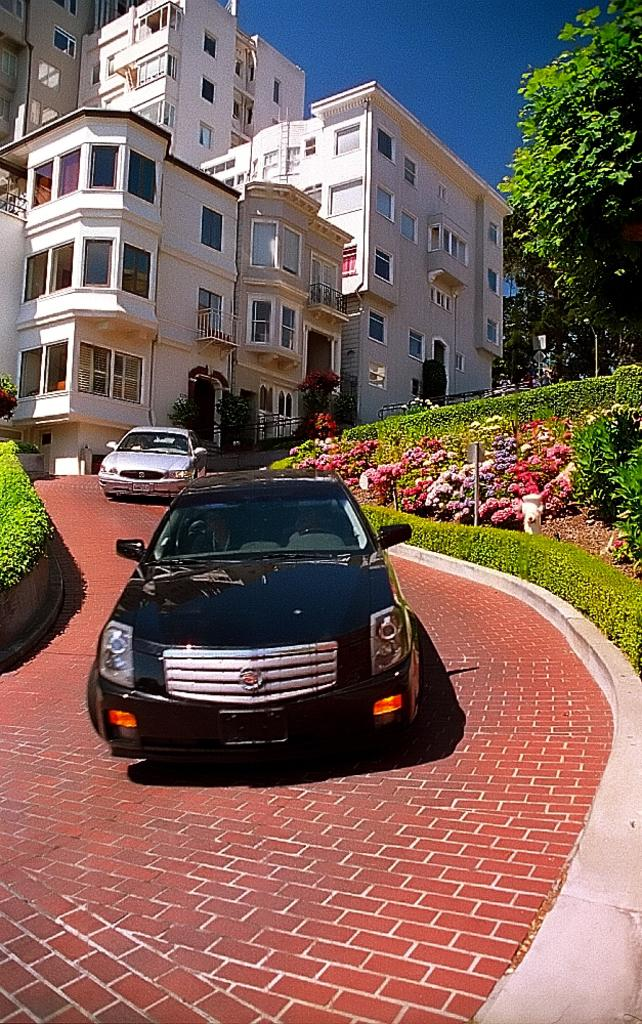What can be seen on the road in the image? There are cars parked on the road in the image. What is present on the plants in the image? There are flowers on the plants in the image. How many trees are visible in the image? There are many trees in the image. What type of structures can be seen in the image? There are buildings in the image. What is the condition of the sky in the image? The sky is clear in the image. Where is the mine located in the image? There is no mine present in the image. What type of science is being conducted in the image? There is no science being conducted in the image; it features cars, flowers, trees, buildings, and a clear sky. 